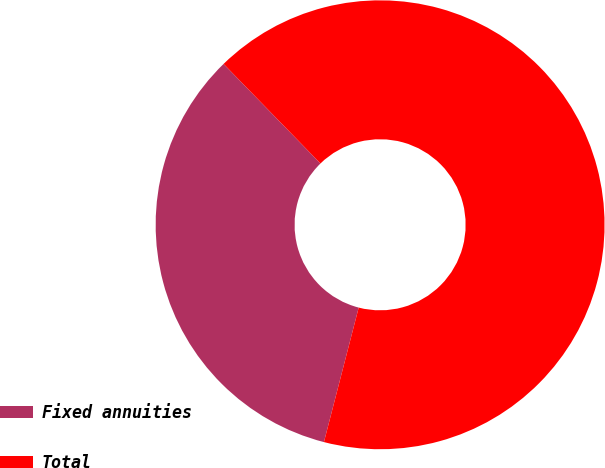Convert chart. <chart><loc_0><loc_0><loc_500><loc_500><pie_chart><fcel>Fixed annuities<fcel>Total<nl><fcel>33.69%<fcel>66.31%<nl></chart> 